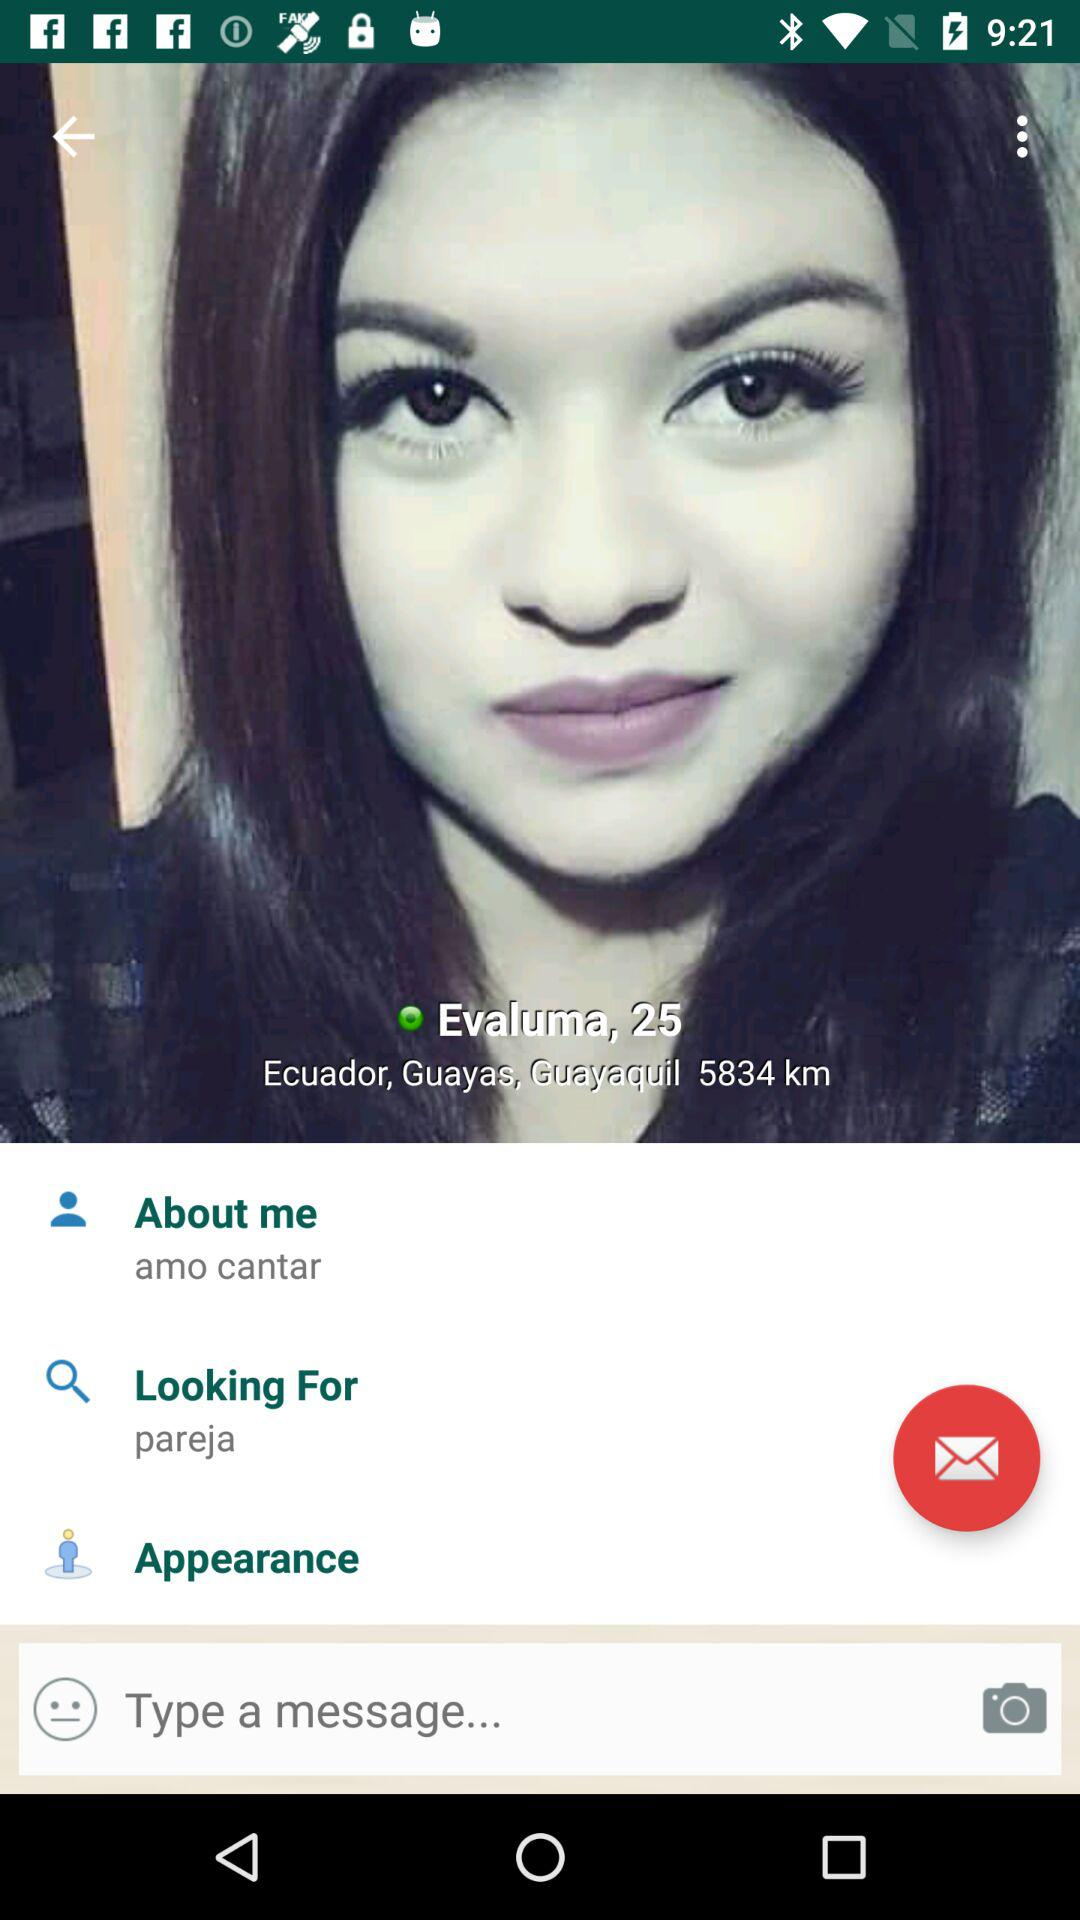What is the name of the user? The name of the user is Evaluma. 